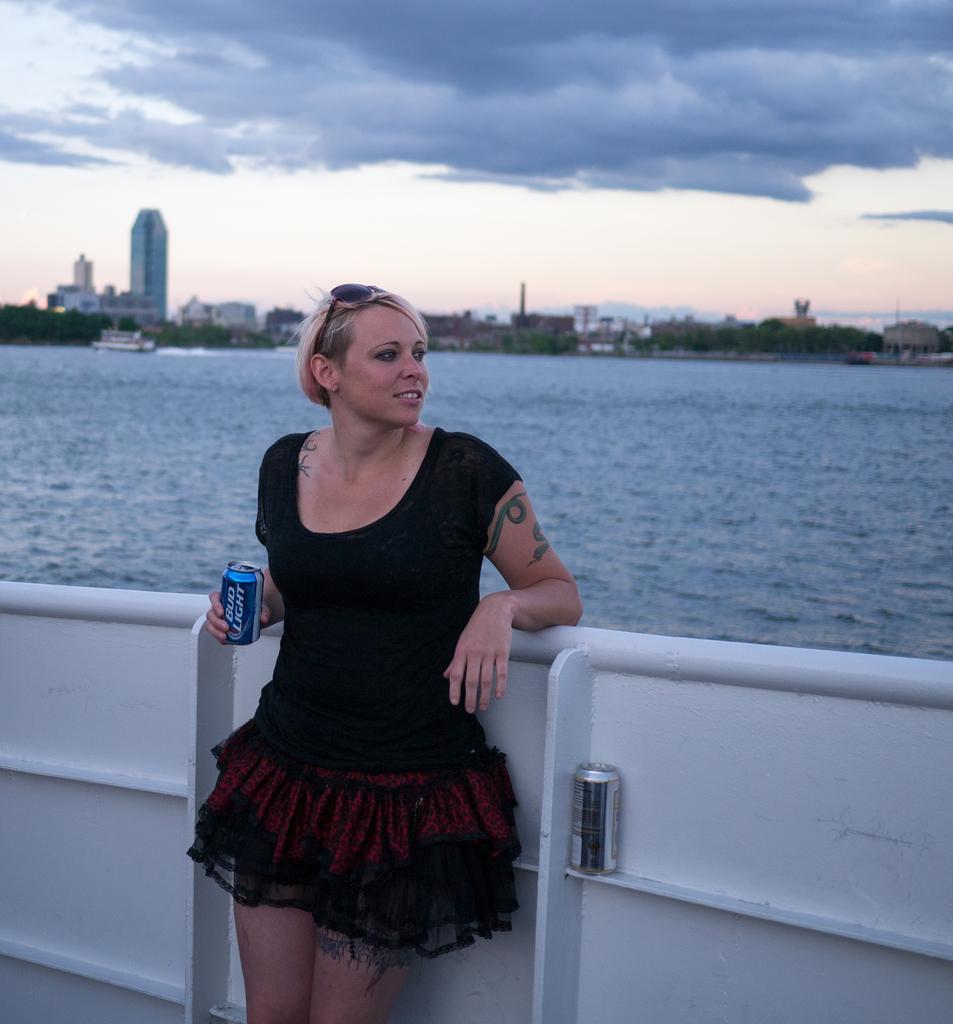Describe this image in one or two sentences. In this image I can see a woman is standing in the front and behind her I can see a white colour thing. I can also see she is holding a can and on her head I can see a shades. I can also see she is wearing black colour dress and on the right side of this image I can see one more can. In the background I can see water, number of trees, number of buildings, clouds, the sky and a boat on the water. 